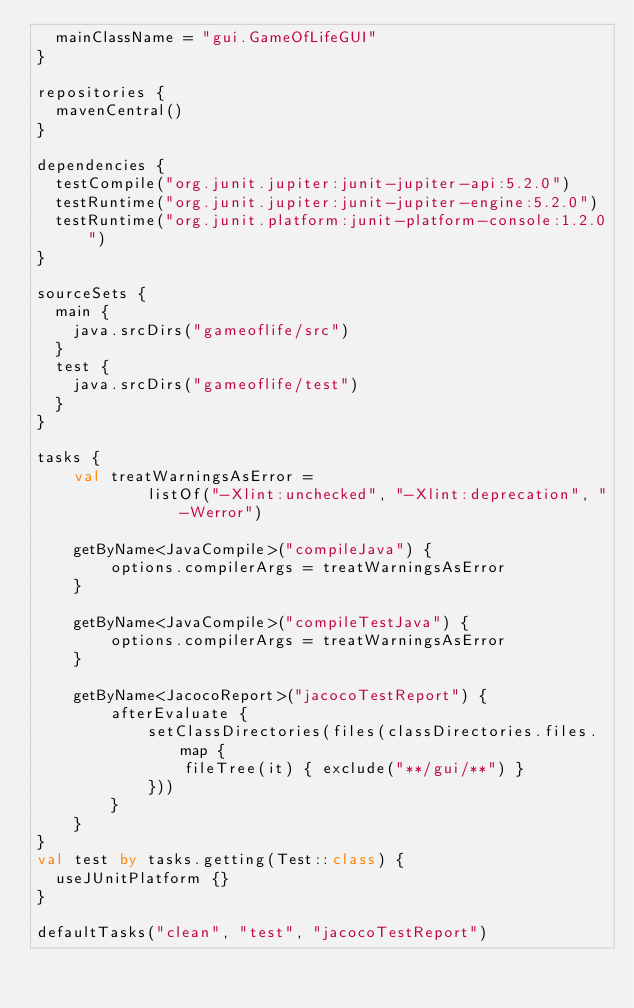Convert code to text. <code><loc_0><loc_0><loc_500><loc_500><_Kotlin_>  mainClassName = "gui.GameOfLifeGUI"
}

repositories {
	mavenCentral()
}

dependencies {
  testCompile("org.junit.jupiter:junit-jupiter-api:5.2.0")
	testRuntime("org.junit.jupiter:junit-jupiter-engine:5.2.0")
	testRuntime("org.junit.platform:junit-platform-console:1.2.0")
}
 
sourceSets {
  main {
    java.srcDirs("gameoflife/src")
  }
  test {
    java.srcDirs("gameoflife/test")
  }
}

tasks {
    val treatWarningsAsError =
            listOf("-Xlint:unchecked", "-Xlint:deprecation", "-Werror")

    getByName<JavaCompile>("compileJava") {
        options.compilerArgs = treatWarningsAsError
    }

    getByName<JavaCompile>("compileTestJava") {
        options.compilerArgs = treatWarningsAsError
    }

    getByName<JacocoReport>("jacocoTestReport") {
        afterEvaluate {
            setClassDirectories(files(classDirectories.files.map {
                fileTree(it) { exclude("**/gui/**") }
            }))
        }
    }
}
val test by tasks.getting(Test::class) {
	useJUnitPlatform {}
}
 
defaultTasks("clean", "test", "jacocoTestReport")
</code> 